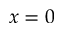<formula> <loc_0><loc_0><loc_500><loc_500>x = 0</formula> 